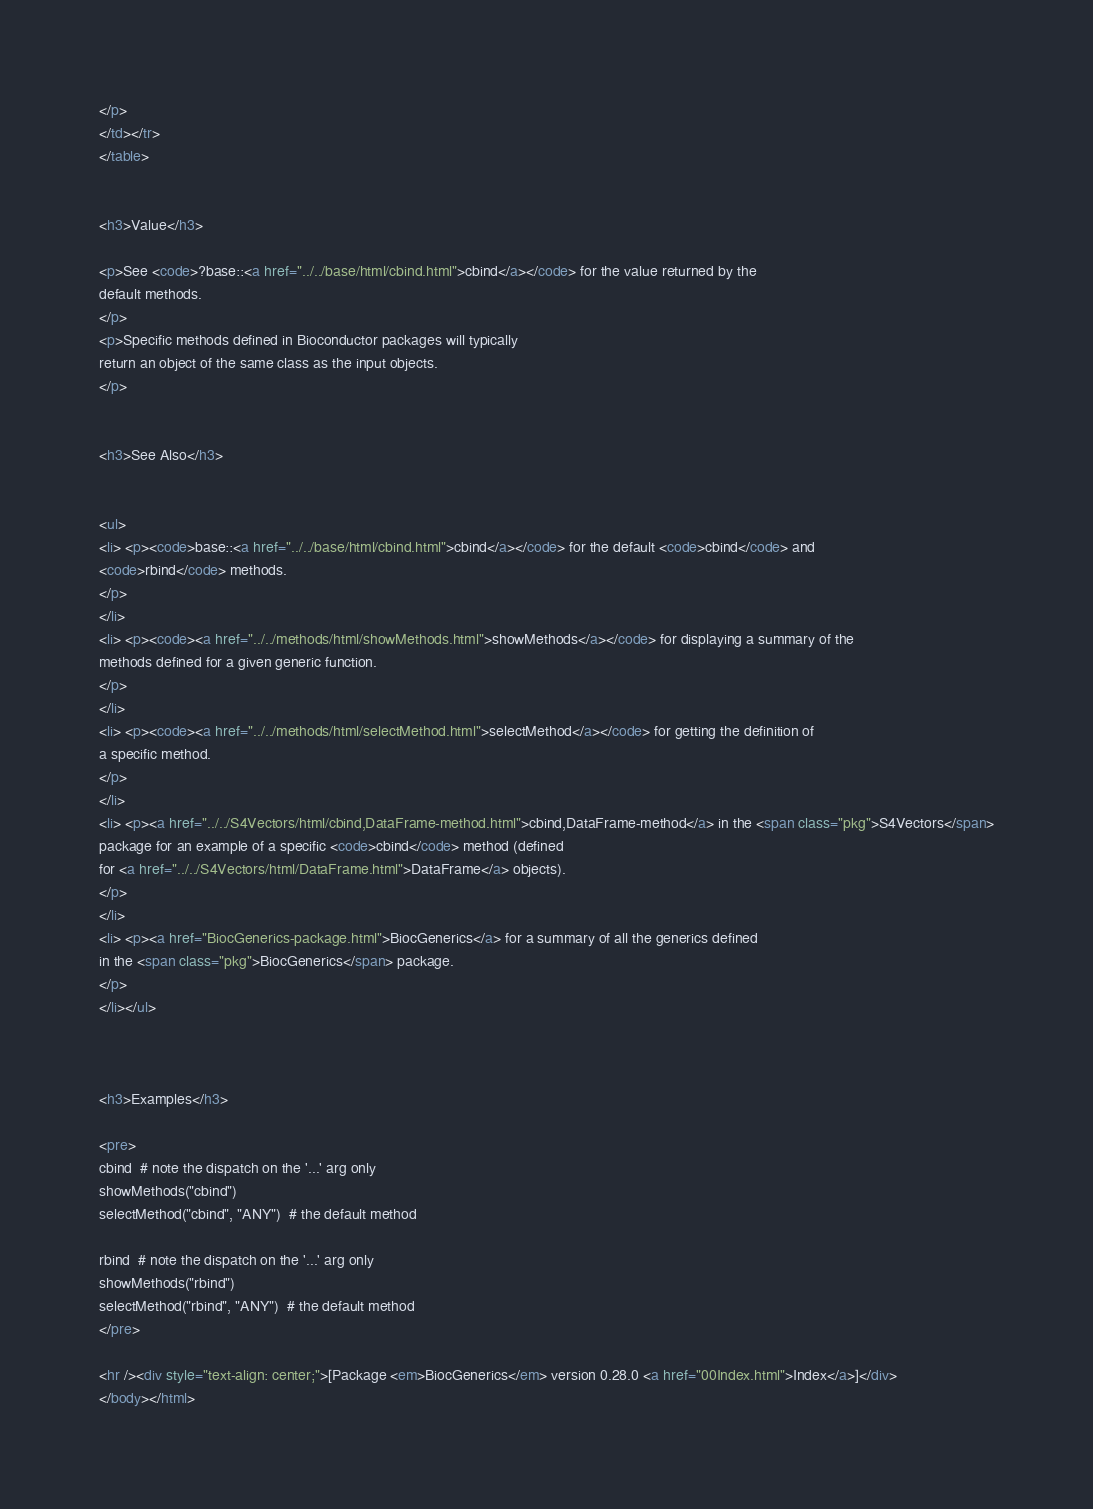Convert code to text. <code><loc_0><loc_0><loc_500><loc_500><_HTML_></p>
</td></tr>
</table>


<h3>Value</h3>

<p>See <code>?base::<a href="../../base/html/cbind.html">cbind</a></code> for the value returned by the
default methods.
</p>
<p>Specific methods defined in Bioconductor packages will typically
return an object of the same class as the input objects.
</p>


<h3>See Also</h3>


<ul>
<li> <p><code>base::<a href="../../base/html/cbind.html">cbind</a></code> for the default <code>cbind</code> and
<code>rbind</code> methods.
</p>
</li>
<li> <p><code><a href="../../methods/html/showMethods.html">showMethods</a></code> for displaying a summary of the
methods defined for a given generic function.
</p>
</li>
<li> <p><code><a href="../../methods/html/selectMethod.html">selectMethod</a></code> for getting the definition of
a specific method.
</p>
</li>
<li> <p><a href="../../S4Vectors/html/cbind,DataFrame-method.html">cbind,DataFrame-method</a> in the <span class="pkg">S4Vectors</span>
package for an example of a specific <code>cbind</code> method (defined
for <a href="../../S4Vectors/html/DataFrame.html">DataFrame</a> objects).
</p>
</li>
<li> <p><a href="BiocGenerics-package.html">BiocGenerics</a> for a summary of all the generics defined
in the <span class="pkg">BiocGenerics</span> package.
</p>
</li></ul>



<h3>Examples</h3>

<pre>
cbind  # note the dispatch on the '...' arg only
showMethods("cbind")
selectMethod("cbind", "ANY")  # the default method

rbind  # note the dispatch on the '...' arg only
showMethods("rbind")
selectMethod("rbind", "ANY")  # the default method
</pre>

<hr /><div style="text-align: center;">[Package <em>BiocGenerics</em> version 0.28.0 <a href="00Index.html">Index</a>]</div>
</body></html>
</code> 